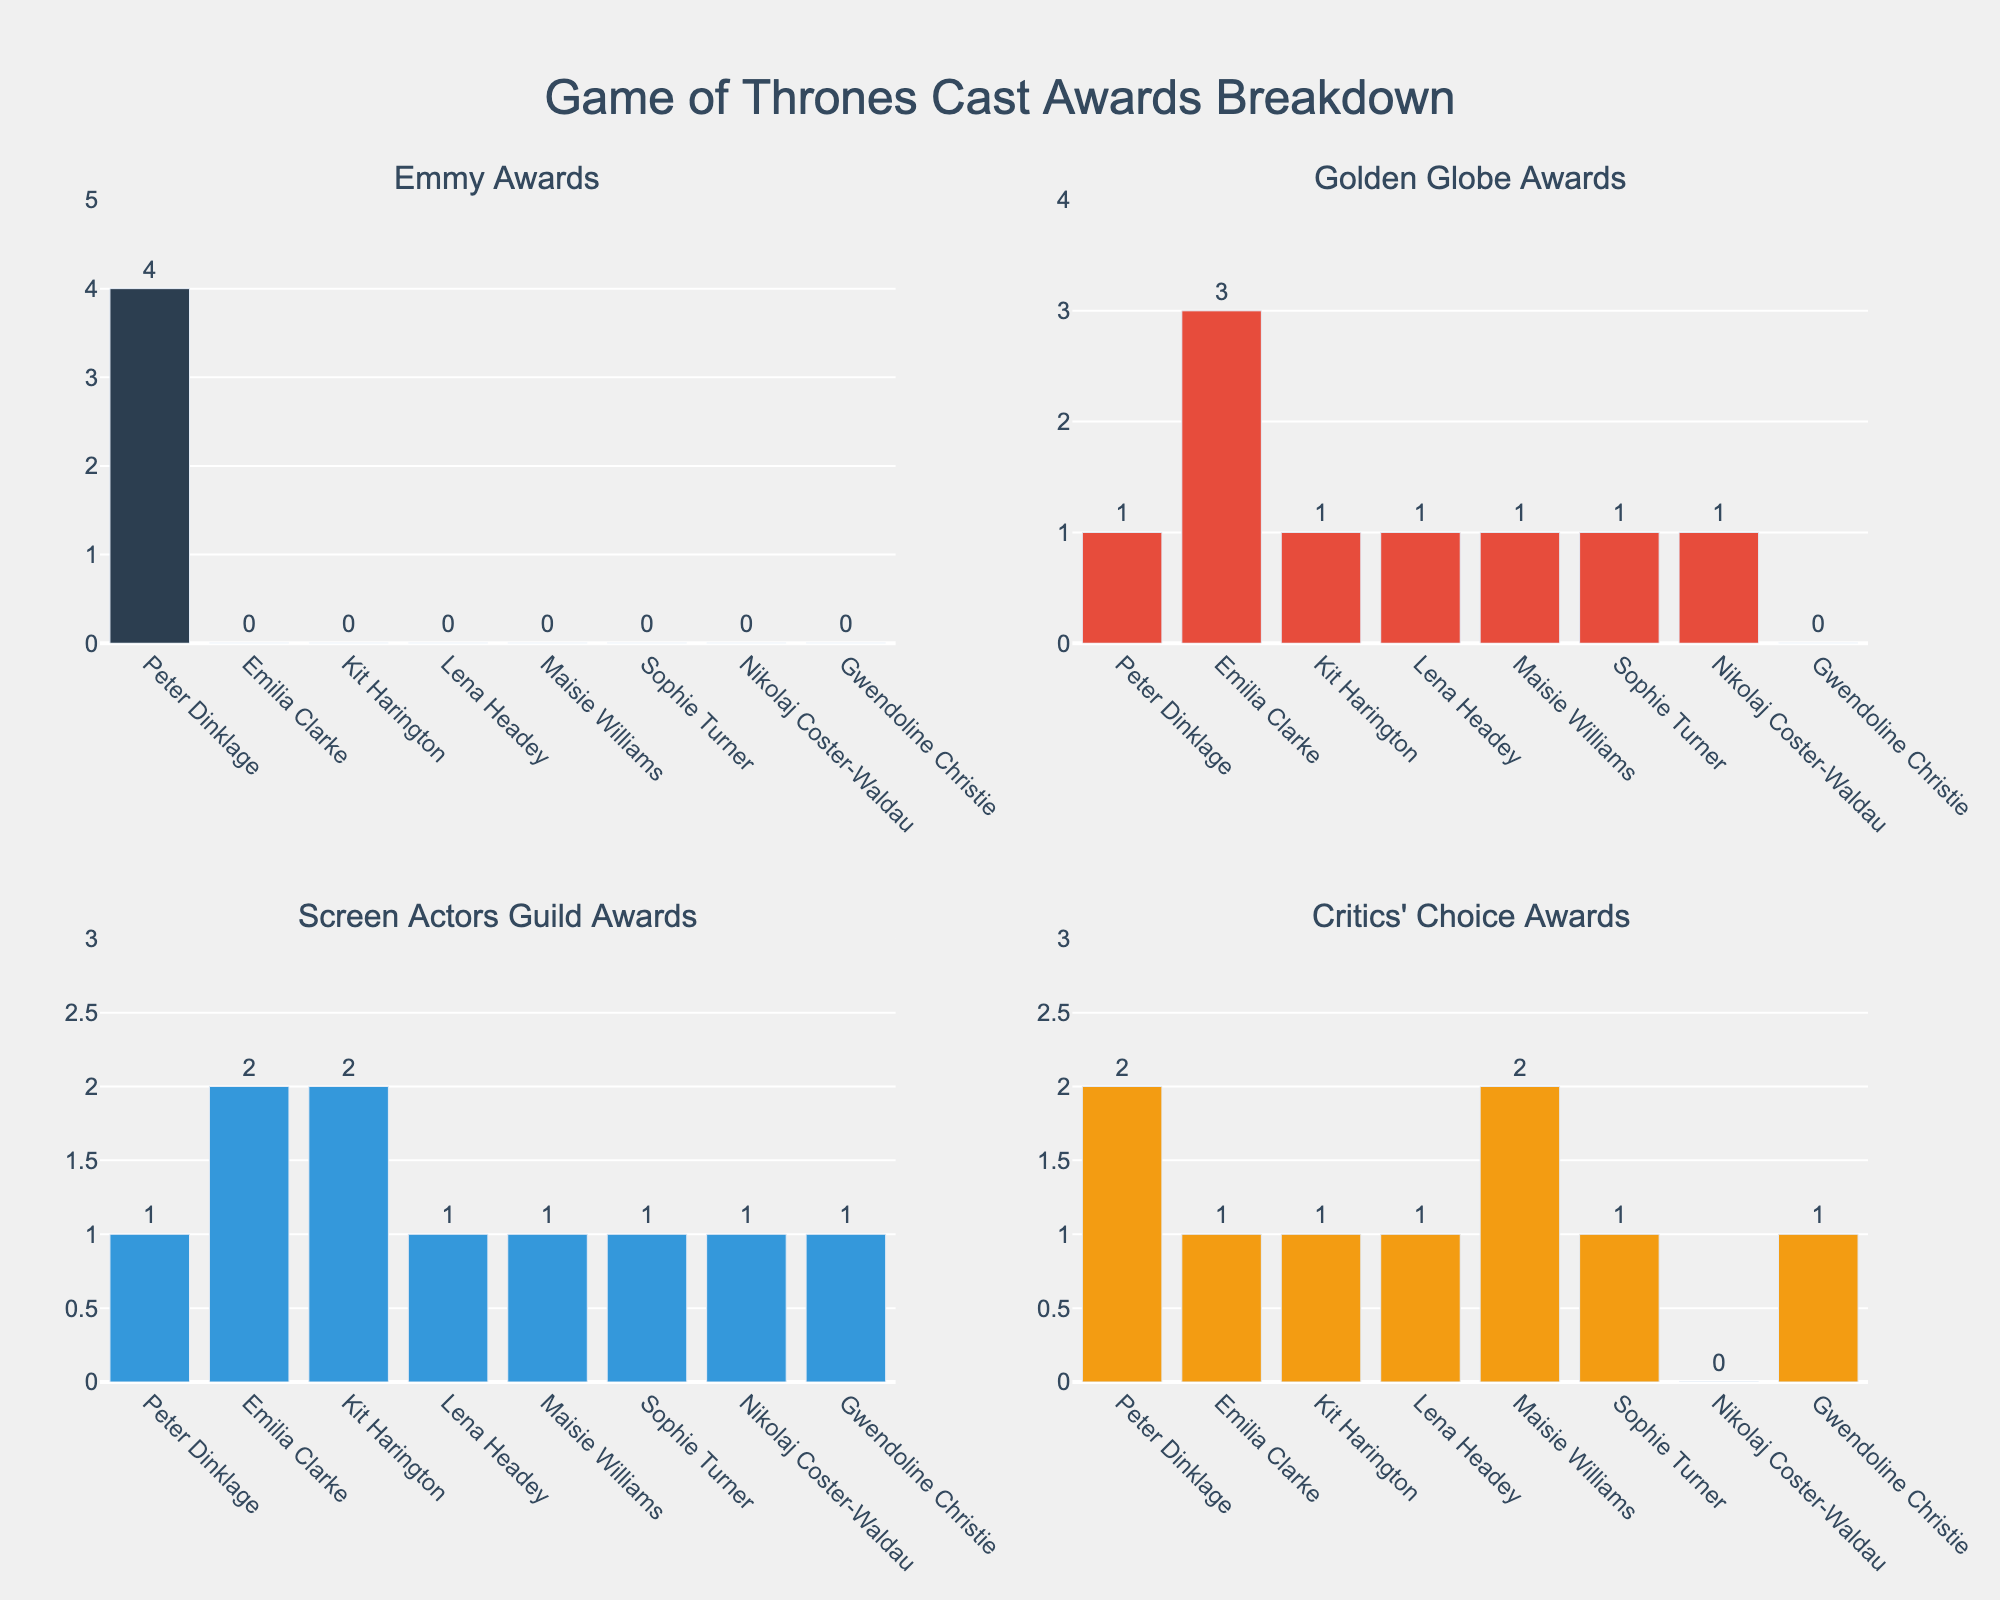Which actor has won the most Emmy Awards? By observing the top left subplot for Emmy Awards, the actor with the tallest bar is Peter Dinklage.
Answer: Peter Dinklage How many Golden Globe Awards has Emilia Clarke won compared to Kit Harington? In the top right subplot for Golden Globe Awards, Emilia Clarke has 3 awards while Kit Harington has 1 award. The difference is 3 - 1.
Answer: 2 Who has the highest number of Screen Actors Guild Awards? Looking at the bottom left subplot for Screen Actors Guild Awards, both Emilia Clarke and Kit Harington have the same tallest bars with 2 awards each.
Answer: Emilia Clarke and Kit Harington What's the total number of Critics' Choice Awards received by all actors? In the bottom right subplot for Critics' Choice Awards, sum the values of all bars: 2 + 1 + 1 + 1 + 2 + 1 + 0 + 1 = 9.
Answer: 9 Compare the number of awards won by Lena Headey and Maisie Williams in all categories. Who has more? Sum Lena Headey's awards: 0 (Emmy) + 1 (Golden Globe) + 1 (SAG) + 1 (Critics' Choice) = 3. Sum Maisie Williams' awards: 0 (Emmy) + 1 (Golden Globe) + 1 (SAG) + 2 (Critics' Choice) = 4.
Answer: Maisie Williams Which category has the highest number of total awards won by all actors? Add the total awards for each category: \
Emmy Awards: 4 (Peter Dinklage).\
Golden Globe Awards: 1 (Peter Dinklage) + 3 (Emilia Clarke) + 1 (Kit Harington) + 1 (Lena Headey) + 1 (Maisie Williams) + 1 (Sophie Turner) + 1 (Nikolaj Coster-Waldau) = 9.\
Screen Actors Guild Awards: 1 (Peter Dinklage) + 2 (Emilia Clarke) + 2 (Kit Harington) + 1 (Lena Headey) + 1 (Maisie Williams) + 1 (Sophie Turner) + 1 (Nikolaj Coster-Waldau) + 1 (Gwendoline Christie) = 10.\
Critics' Choice Awards: 2 (Peter Dinklage) + 1 (Emilia Clarke) + 1 (Kit Harington) + 1 (Lena Headey) + 2 (Maisie Williams) + 1 (Sophie Turner) + 1 (Gwendoline Christie) = 9.\
Screen Actors Guild Awards has the highest total with 10.
Answer: Screen Actors Guild Awards What's the difference in the total number of Emmy Awards and Golden Globe Awards won by all actors? Emmy Awards total: 4. Golden Globe Awards total: 9. Difference: 9 - 4.
Answer: 5 How many actors have won at least one Critics' Choice Award? In the bottom right subplot for Critics' Choice Awards, count the bars with a positive value: Peter Dinklage, Emilia Clarke, Kit Harington, Lena Headey, Maisie Williams, Sophie Turner, Gwendoline Christie. This gives 7 actors.
Answer: 7 